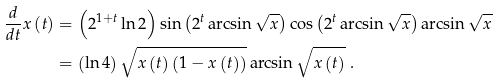<formula> <loc_0><loc_0><loc_500><loc_500>\frac { d } { d t } x \left ( t \right ) & = \left ( 2 ^ { 1 + t } \ln 2 \right ) \sin \left ( 2 ^ { t } \arcsin \sqrt { x } \right ) \cos \left ( 2 ^ { t } \arcsin \sqrt { x } \right ) \arcsin \sqrt { x } \\ & = \left ( \ln 4 \right ) \sqrt { x \left ( t \right ) \left ( 1 - x \left ( t \right ) \right ) } \arcsin \sqrt { x \left ( t \right ) } \ .</formula> 